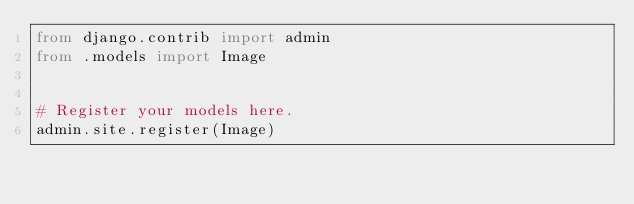<code> <loc_0><loc_0><loc_500><loc_500><_Python_>from django.contrib import admin
from .models import Image


# Register your models here.
admin.site.register(Image)


</code> 